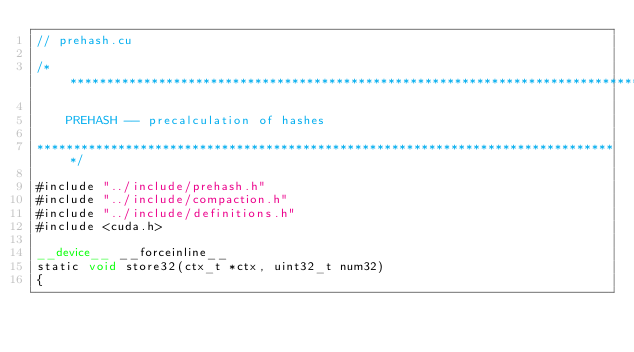<code> <loc_0><loc_0><loc_500><loc_500><_Cuda_>// prehash.cu

/*******************************************************************************

    PREHASH -- precalculation of hashes

*******************************************************************************/

#include "../include/prehash.h"
#include "../include/compaction.h"
#include "../include/definitions.h"
#include <cuda.h>

__device__ __forceinline__
static void store32(ctx_t *ctx, uint32_t num32)
{</code> 